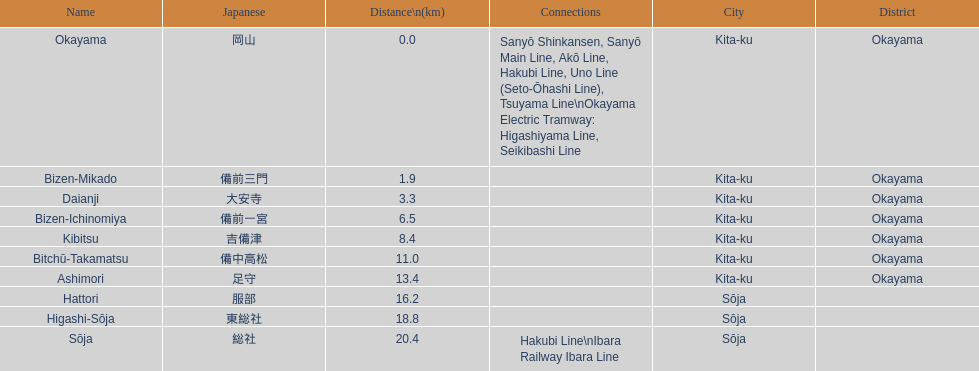How many consecutive stops must you travel through is you board the kibi line at bizen-mikado at depart at kibitsu? 2. 